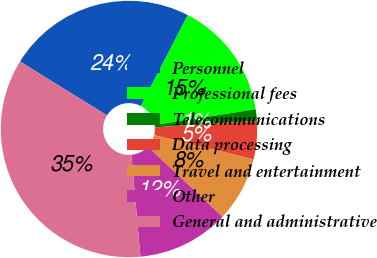<chart> <loc_0><loc_0><loc_500><loc_500><pie_chart><fcel>Personnel<fcel>Professional fees<fcel>Telecommunications<fcel>Data processing<fcel>Travel and entertainment<fcel>Other<fcel>General and administrative<nl><fcel>23.76%<fcel>14.96%<fcel>1.44%<fcel>4.82%<fcel>8.2%<fcel>11.58%<fcel>35.25%<nl></chart> 